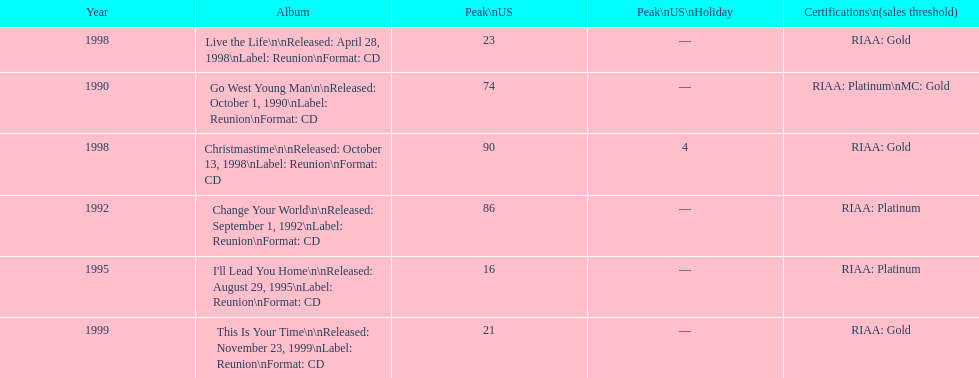What is the number of michael w smith albums that made it to the top 25 of the charts? 3. 